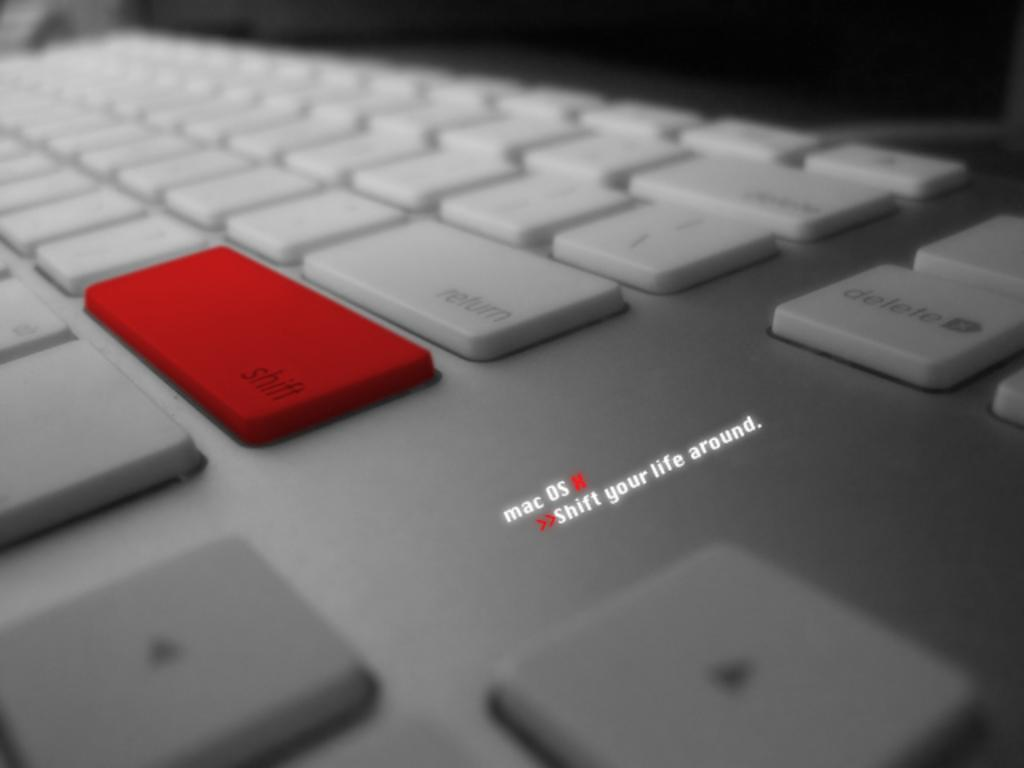<image>
Give a short and clear explanation of the subsequent image. a red Shift key on a keyboard with the words Mac OS X Shift your life around 